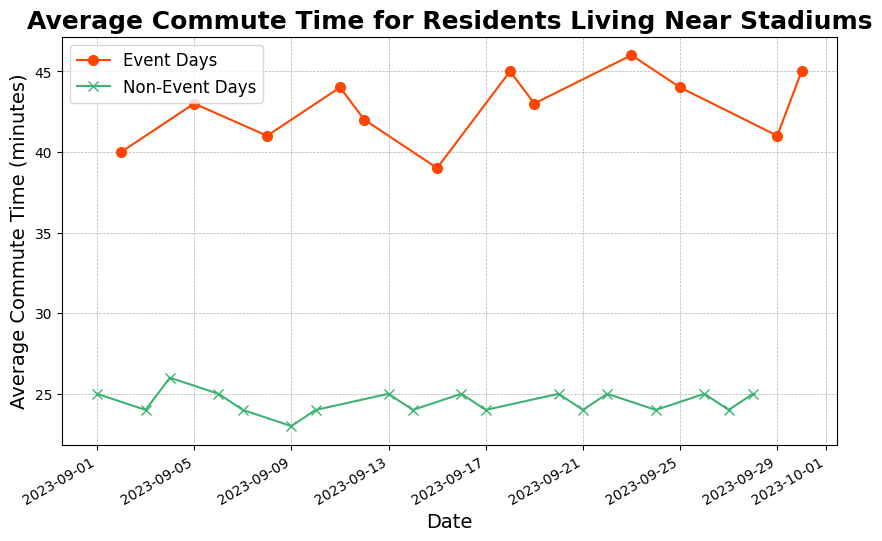What's the average commute time on event days? Calculate the average commute time by summing up all the commute times on event days and dividing by the number of event days. The event days have these times: 40, 43, 41, 44, 42, 39, 45, 43, 46, 44, 41, 45. So, (40 + 43 + 41 + 44 + 42 + 39 + 45 + 43 + 46 + 44 + 41 + 45) / 12 = 513 / 12 ≈ 42.75
Answer: 42.75 How does the average commute time on non-event days compare to that on event days? First, calculate the average for non-event days: (25 + 24 + 26 + 25 + 24 + 23 + 24 + 25 + 24 + 25 + 24 + 25 + 24 + 25) / 14 = 337 / 14 ≈ 24.07. Compare with the average for event days which is 42.75. The average commute time on event days is significantly higher than on non-event days.
Answer: Event days have a higher average commute time What is the highest recorded commute time on the plot? Identify the data point with the highest average commute time by visually checking the highest point on the y-axis. The highest point is at 46 minutes on September 23rd.
Answer: 46 minutes On which dates did the commute times exceed 40 minutes on event days? Look at the dates where the line for event days peaks above 40 minutes. Those dates are September 2nd, 5th, 8th, 11th, 12th, 18th, 19th, 23rd, 25th, and 30th.
Answer: September 2, 5, 8, 11, 12, 18, 19, 23, 25, 30 How do the commute times on event days vary compared to non-event days in terms of consistency? Evaluate the variability of commute times by examining the spikes and drops. Non-event days have relatively consistent commute times around 24-26 minutes, while event days show large variations between 39-46 minutes.
Answer: Event days are more variable What's the most common commute time on non-event days? Observe the recurring values on non-event days; most values range around 24-25 minutes. The most frequently occurring commute time is clearly 24 minutes.
Answer: 24 minutes Which date has the lowest average commute time and what is that time? Find the lowest point on the plot for non-event days, as they generally have lower times. The lowest times appear around 23 minutes on September 9th.
Answer: September 9, 23 minutes What is the difference in commute time between event and non-event days on September 2nd and 3rd? Check the plotted points for September 2nd (event) and 3rd (non-event). Commute times are 40 and 24 minutes respectively. The difference is 40 - 24 = 16 minutes.
Answer: 16 minutes During what period does the commute time remain consistently low? Identify stretches in the plot where the non-event line remains flat. Notably, from September 3rd to September 4th and several other clusters, the commute time is fairly stable around 24-25 minutes.
Answer: September 3-4 and other clusters Is there a correlation between event days and higher commute times? Compare the heights of markers for event versus non-event days. Event days have consistently higher commute times as shown by taller markers in the orange line compared to the green line.
Answer: Yes, higher on event days 